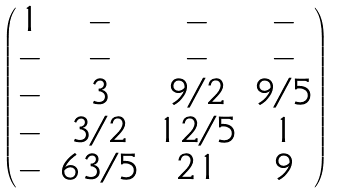Convert formula to latex. <formula><loc_0><loc_0><loc_500><loc_500>\begin{pmatrix} 1 & - & - & - \\ - & - & - & - \\ - & 3 & 9 / 2 & 9 / 5 \\ - & 3 / 2 & 1 2 / 5 & 1 \\ - & 6 3 / 5 & 2 1 & 9 \end{pmatrix}</formula> 